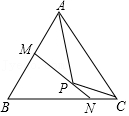Why does the line MN pass through point P and what could be its significance? The line MN appears to pass through point P to form intersections with the triangle's sides at points M and N. This configuration might suggest that P is the centroid of the triangle, which is the point where the triangle's medians intersect, thus dividing each median into two segments that have a 2:1 ratio. 